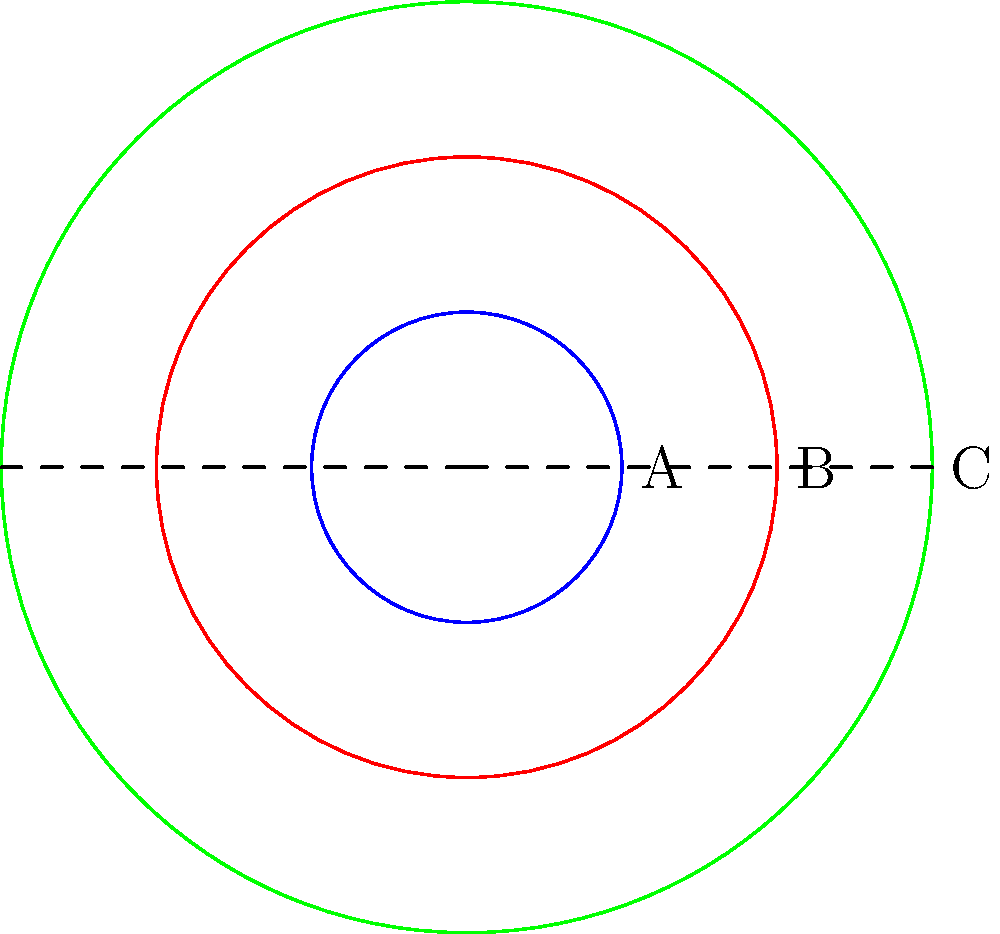In the context of the hero's journey narrative, the concentric circles represent different stages of the protagonist's transformation. If circle A represents the hero's initial state, and circle C represents their final transformed state, what scale factor would symbolize the hero's overall growth from beginning to end? How might this mathematical representation challenge our understanding of personal growth in mythological narratives? To answer this question, we need to follow these steps:

1. Identify the radii of the circles:
   Circle A (initial state): $r_1 = 1$
   Circle B (intermediate state): $r_2 = 2$
   Circle C (final state): $r_3 = 3$

2. Calculate the scale factor from A to C:
   Scale factor = $\frac{r_3}{r_1} = \frac{3}{1} = 3$

3. Interpret the scale factor:
   The scale factor of 3 represents a tripling in size from the initial to the final state.

4. Philosophical interpretation:
   This mathematical representation challenges our understanding of personal growth in mythological narratives by:
   a) Suggesting that growth is quantifiable and uniform.
   b) Implying that the hero's journey results in a finite, measurable transformation.
   c) Raising questions about the nature of personal growth: Is it truly linear and scalable?
   d) Prompting us to consider whether a simple numerical representation can capture the complexity of character development in myths and legends.
   e) Encouraging us to reflect on the limitations of using geometric models to represent abstract concepts like personal growth and transformation.

5. Ethical considerations:
   This model raises moral questions about the value we place on transformation and whether we equate "bigger" with "better" in terms of personal development.
Answer: Scale factor: 3. This geometric representation challenges the simplistic view of personal growth in myths, prompting philosophical inquiry into the nature and measurement of transformation. 